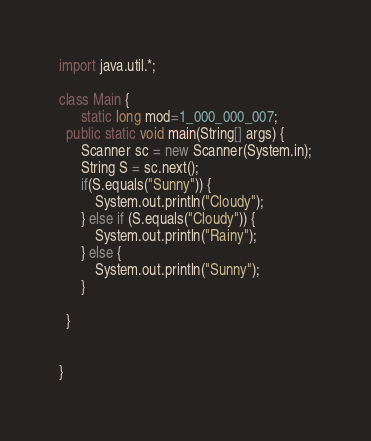<code> <loc_0><loc_0><loc_500><loc_500><_Java_>import java.util.*;

class Main {
	  static long mod=1_000_000_007;
  public static void main(String[] args) {
	  Scanner sc = new Scanner(System.in);
      String S = sc.next();
      if(S.equals("Sunny")) {
    	  System.out.println("Cloudy");    	  
      } else if (S.equals("Cloudy")) {
    	  System.out.println("Rainy"); 
      } else {
    	  System.out.println("Sunny"); 
      }
      
  }
  
 
}</code> 